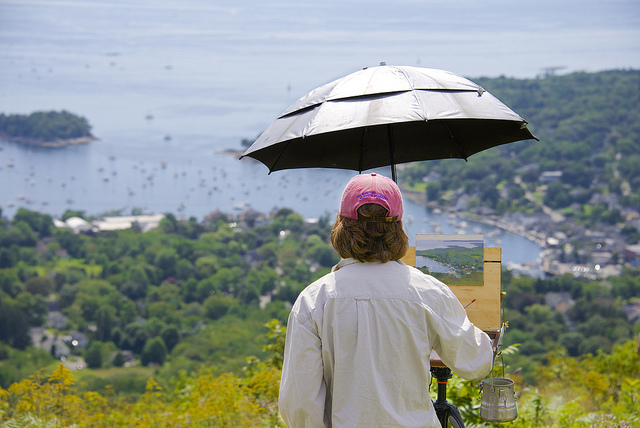What is in the metal tin? Judging from the image, the metal tin appears to contain paint. The individual in the image seems to be using it as a palette for their art, which is suggested by the presence of a canvas and the act of painting outdoors. 